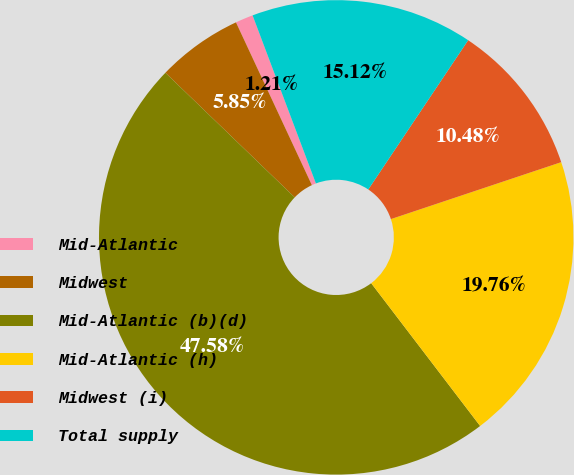<chart> <loc_0><loc_0><loc_500><loc_500><pie_chart><fcel>Mid-Atlantic<fcel>Midwest<fcel>Mid-Atlantic (b)(d)<fcel>Mid-Atlantic (h)<fcel>Midwest (i)<fcel>Total supply<nl><fcel>1.21%<fcel>5.85%<fcel>47.58%<fcel>19.76%<fcel>10.48%<fcel>15.12%<nl></chart> 